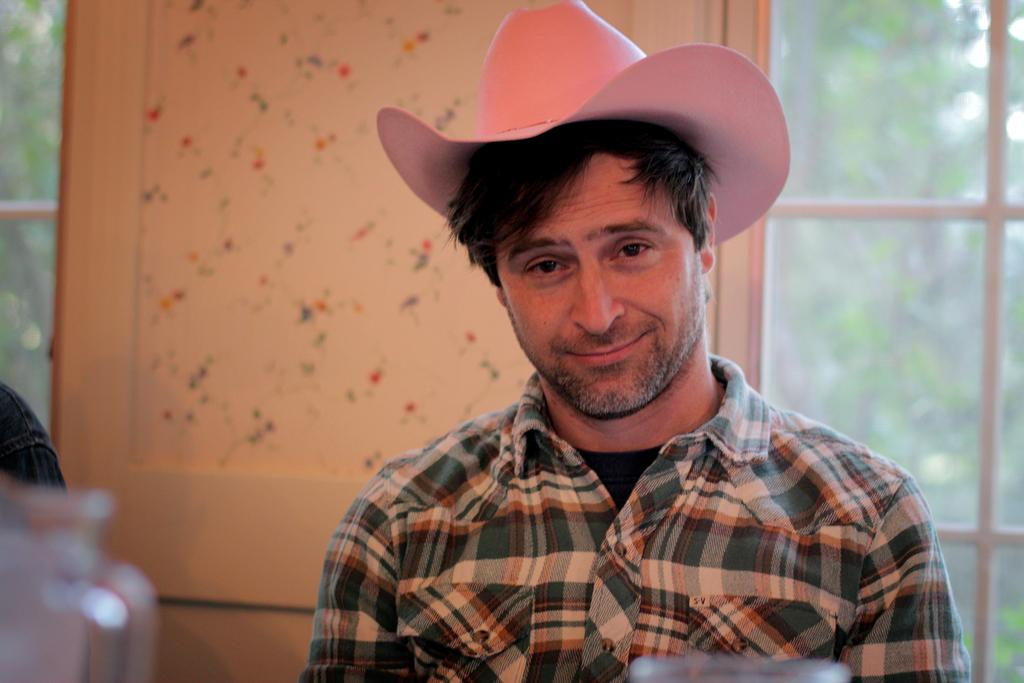Who is the main subject in the image? There is a man in the middle of the image. What is the man wearing on his head? The man is wearing a cap. What can be seen in the background of the image? There are trees in the background of the image. What type of carriage is being pulled by the maid in the image? There is no carriage or maid present in the image; it features a man wearing a cap with trees in the background. 